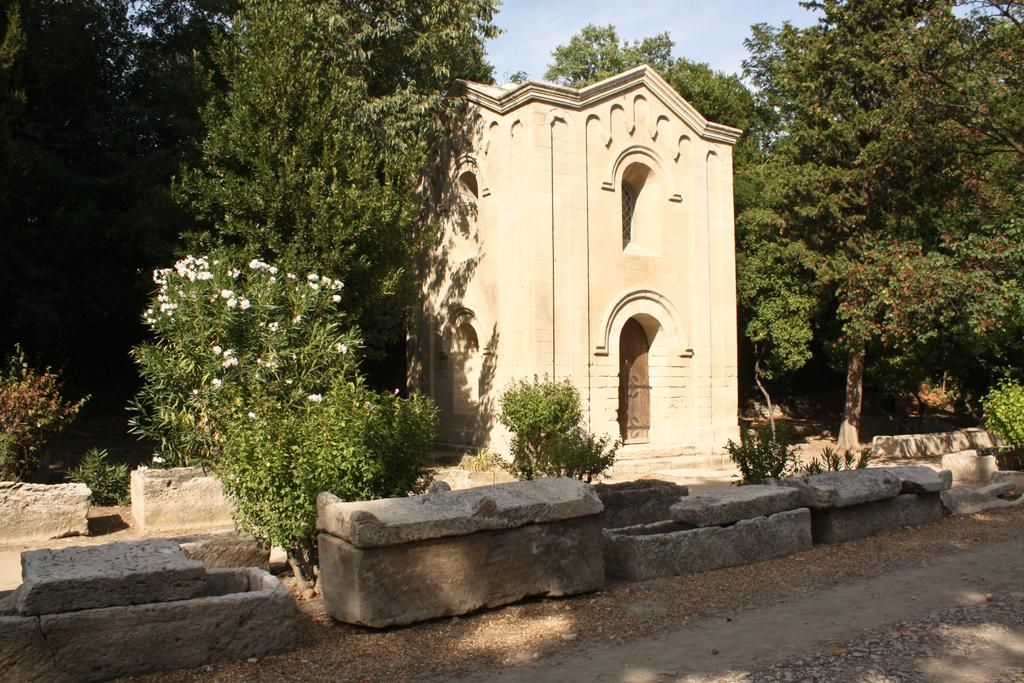What type of vegetation can be seen in the image? There are trees, plants, and shrubs in the image. What part of the natural environment is visible in the image? The sky, ground, and various natural elements like trees, plants, shrubs, stones, and rocks are visible in the image. Can any structures be identified in the image? Yes, there is at least one building present in the image. What type of jelly can be seen on the plot in the image? There is no jelly or plot present in the image. What type of cup is being used to serve the jelly in the image? There is no cup or jelly present in the image. 